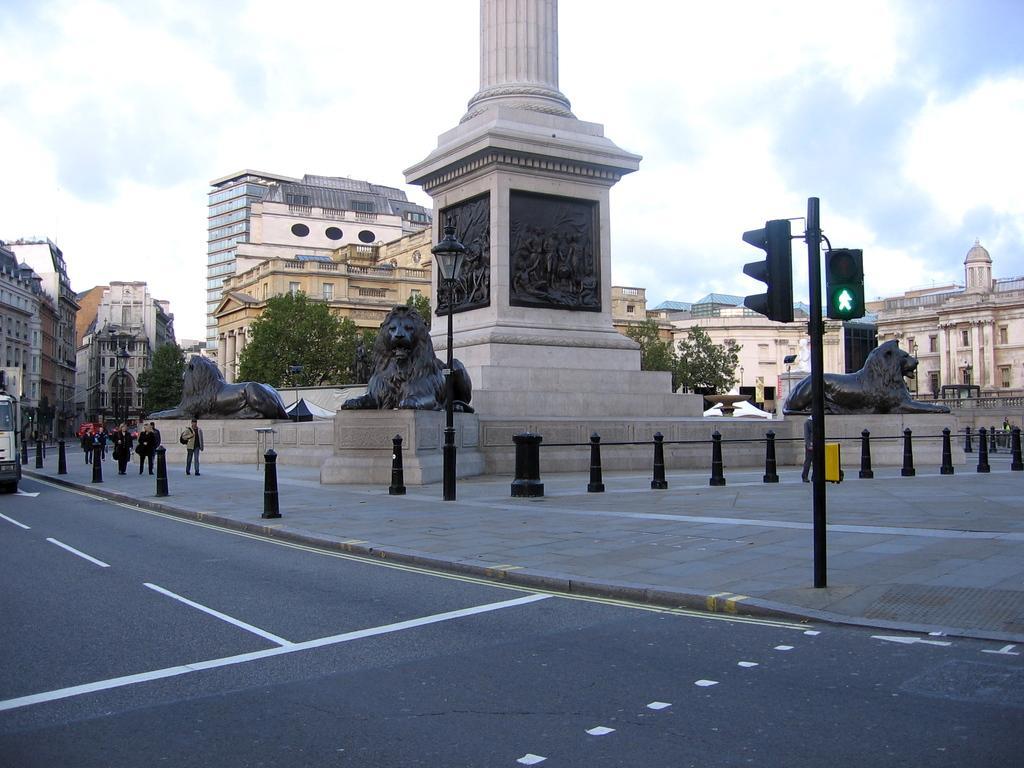How would you summarize this image in a sentence or two? As we can see in the image there are buildings, trees, statues, traffic signals, few people walking here and there, street lamp, vehicle, sky and clouds. 